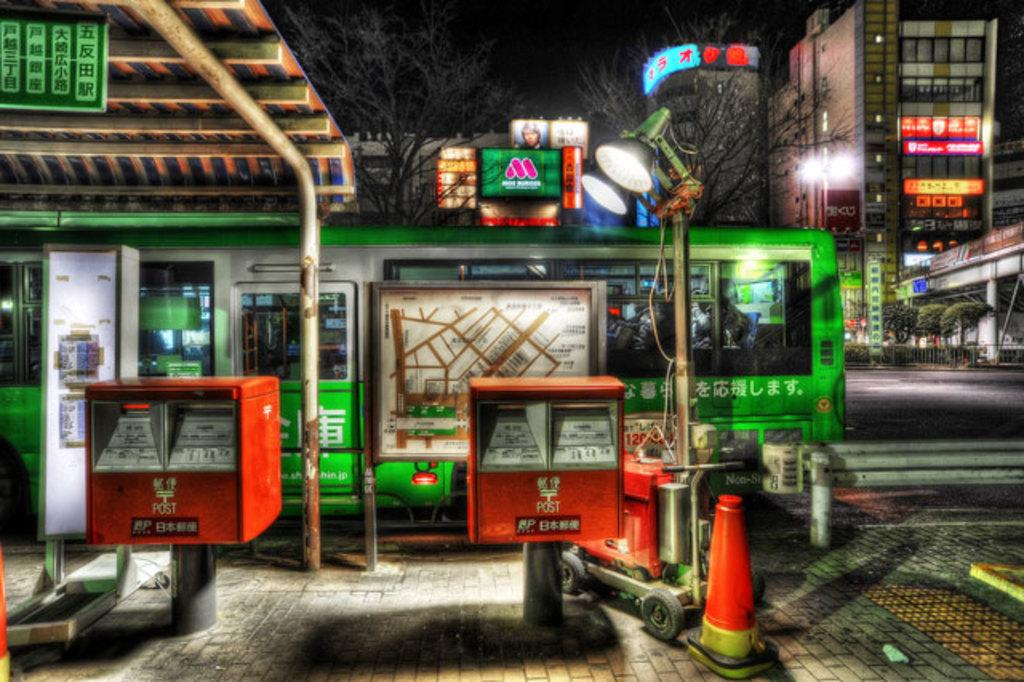<image>
Relay a brief, clear account of the picture shown. Red square stands that say POST on it. 